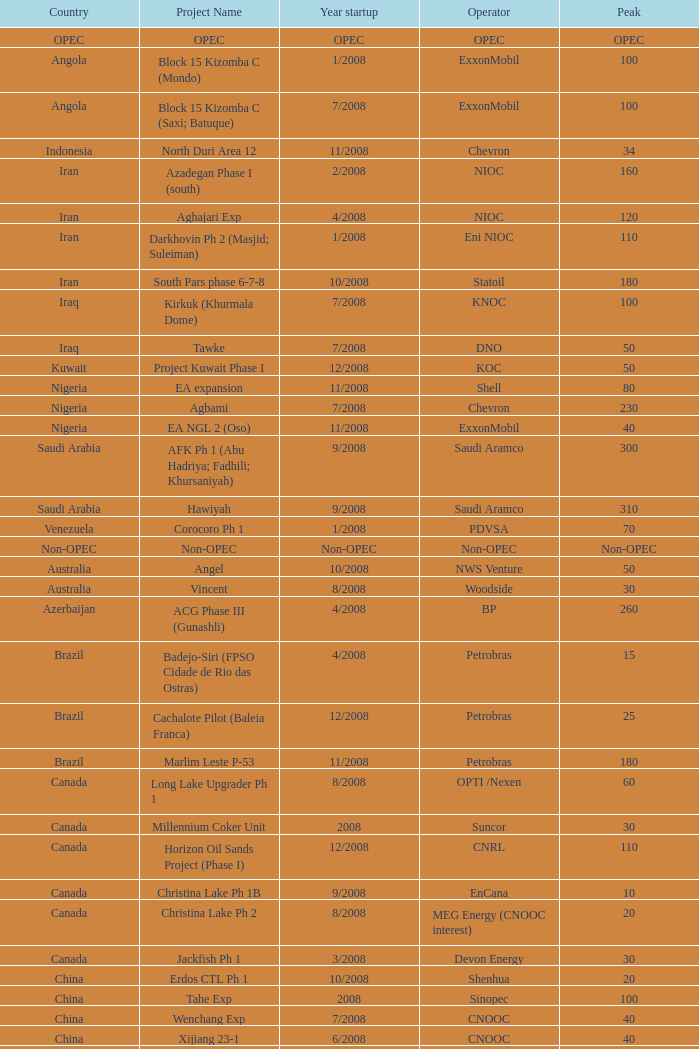Can you provide the project name that involves a country from opec? OPEC. 